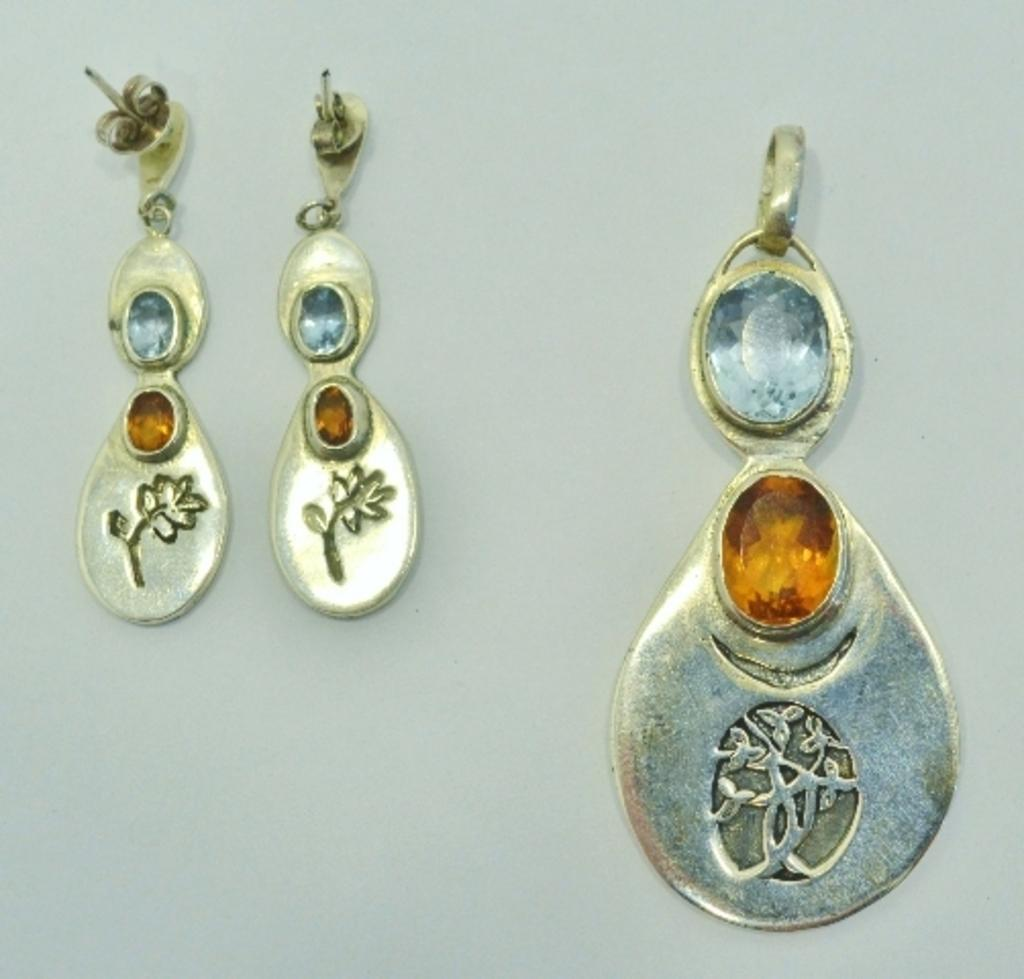What type of accessory is present in the image? There are earrings in the image. Where are the earrings located in the image? The earrings are hanging on the wall. What type of spoon is used to play the musical instrument in the image? There is no spoon or musical instrument present in the image; it only features earrings hanging on the wall. 